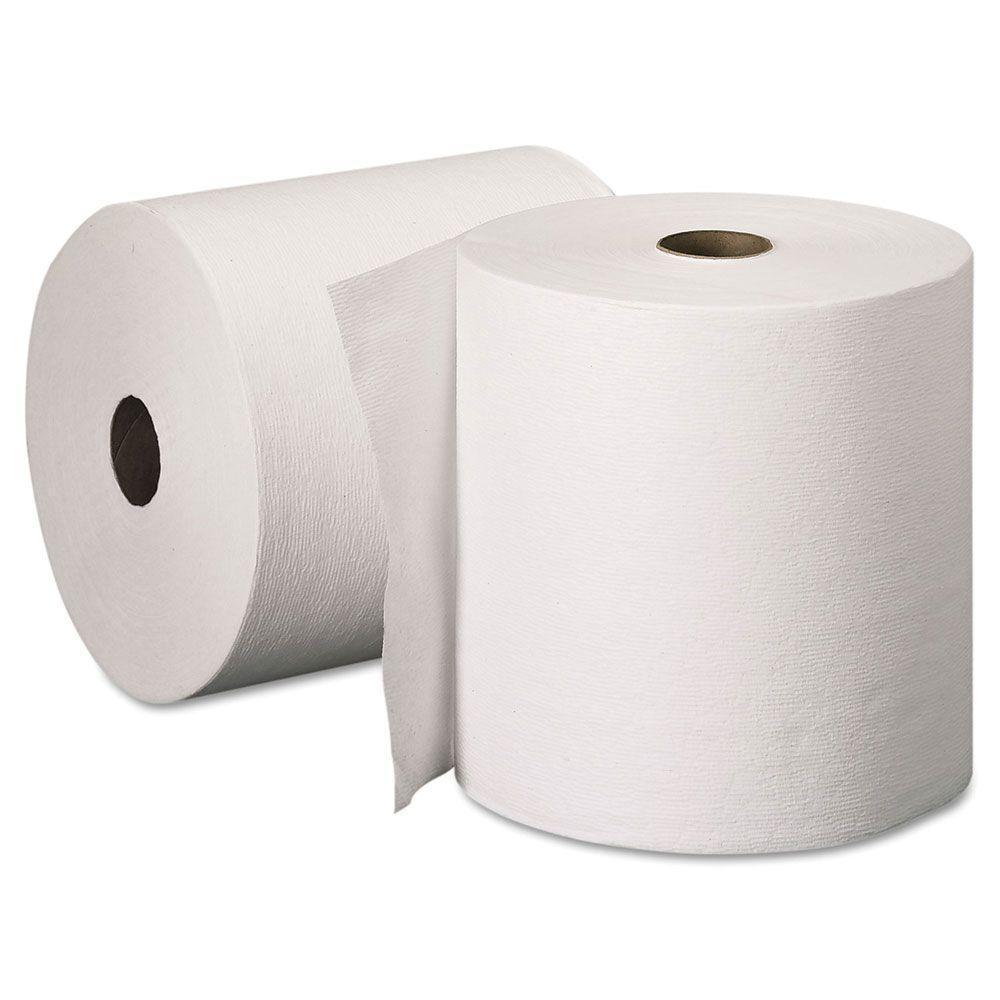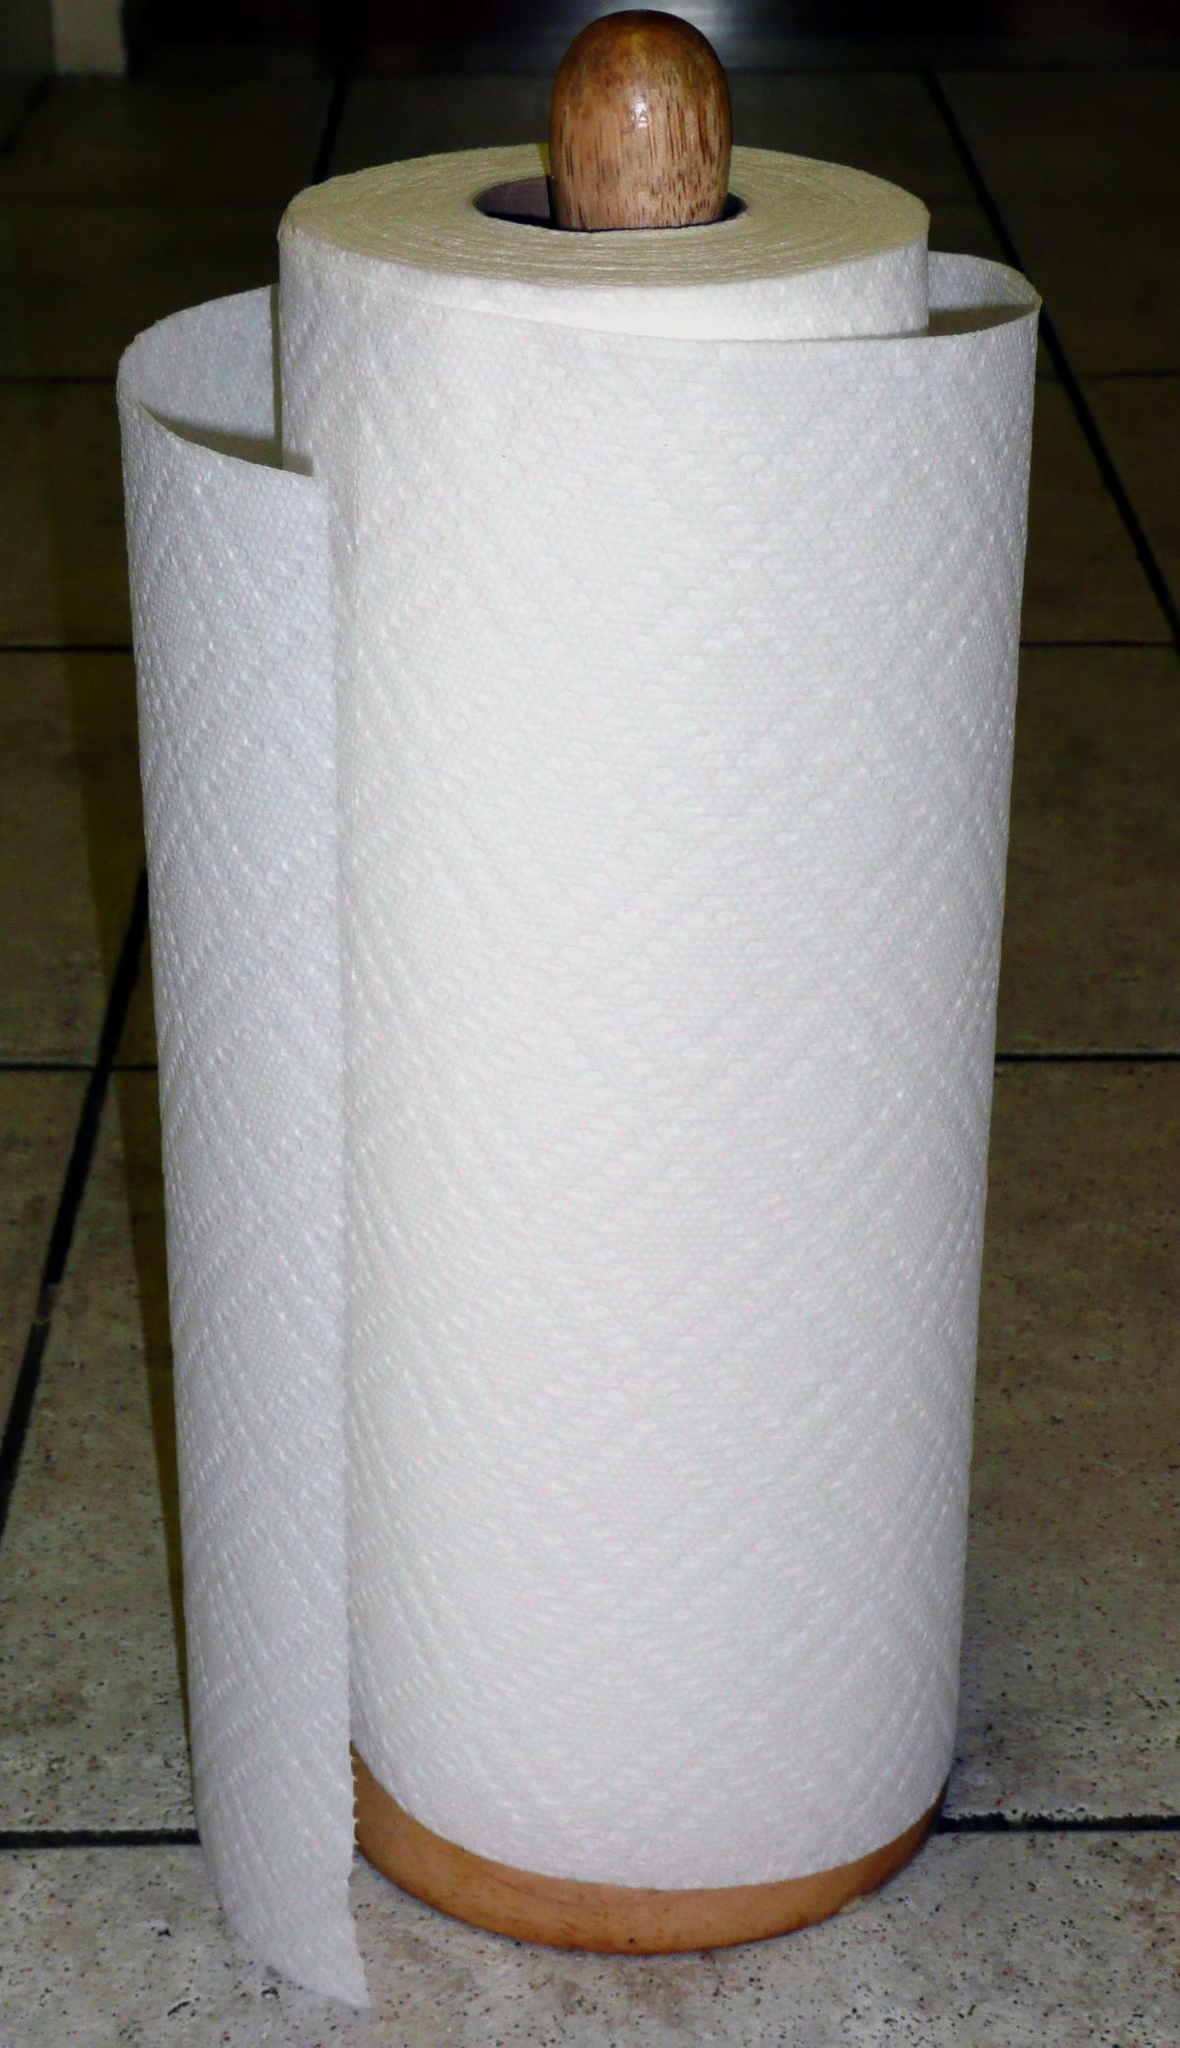The first image is the image on the left, the second image is the image on the right. Evaluate the accuracy of this statement regarding the images: "One image shows exactly one roll standing in front of a roll laying on its side.". Is it true? Answer yes or no. Yes. The first image is the image on the left, the second image is the image on the right. Assess this claim about the two images: "There are three rolls of paper". Correct or not? Answer yes or no. Yes. 